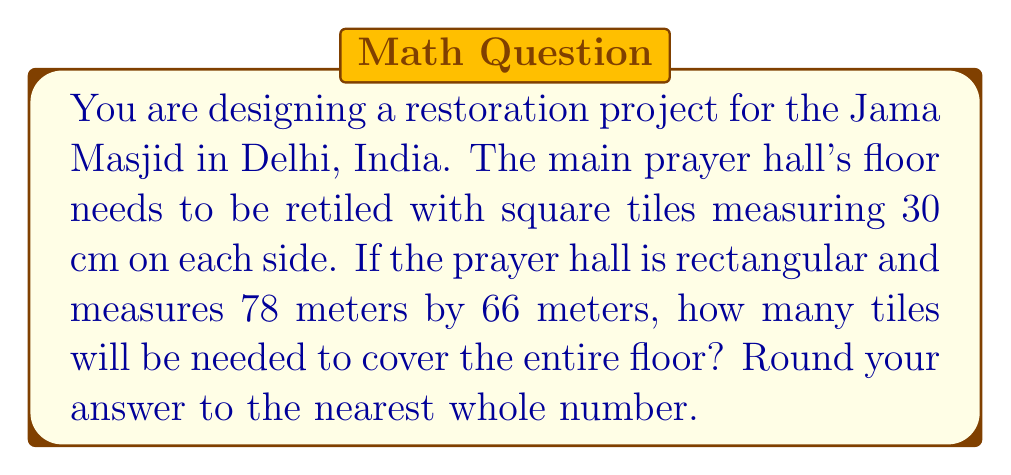What is the answer to this math problem? To solve this problem, we'll follow these steps:

1. Convert the dimensions of the prayer hall from meters to centimeters:
   78 m = 7800 cm
   66 m = 6600 cm

2. Calculate the total area of the prayer hall in square centimeters:
   $$A_{hall} = 7800 \text{ cm} \times 6600 \text{ cm} = 51,480,000 \text{ cm}^2$$

3. Calculate the area of a single tile:
   $$A_{tile} = 30 \text{ cm} \times 30 \text{ cm} = 900 \text{ cm}^2$$

4. Divide the total area of the hall by the area of a single tile:
   $$N_{tiles} = \frac{A_{hall}}{A_{tile}} = \frac{51,480,000 \text{ cm}^2}{900 \text{ cm}^2} = 57,200$$

5. Since we can't use partial tiles, we round to the nearest whole number.

The result is exactly 57,200, so no rounding is necessary.
Answer: 57,200 tiles 